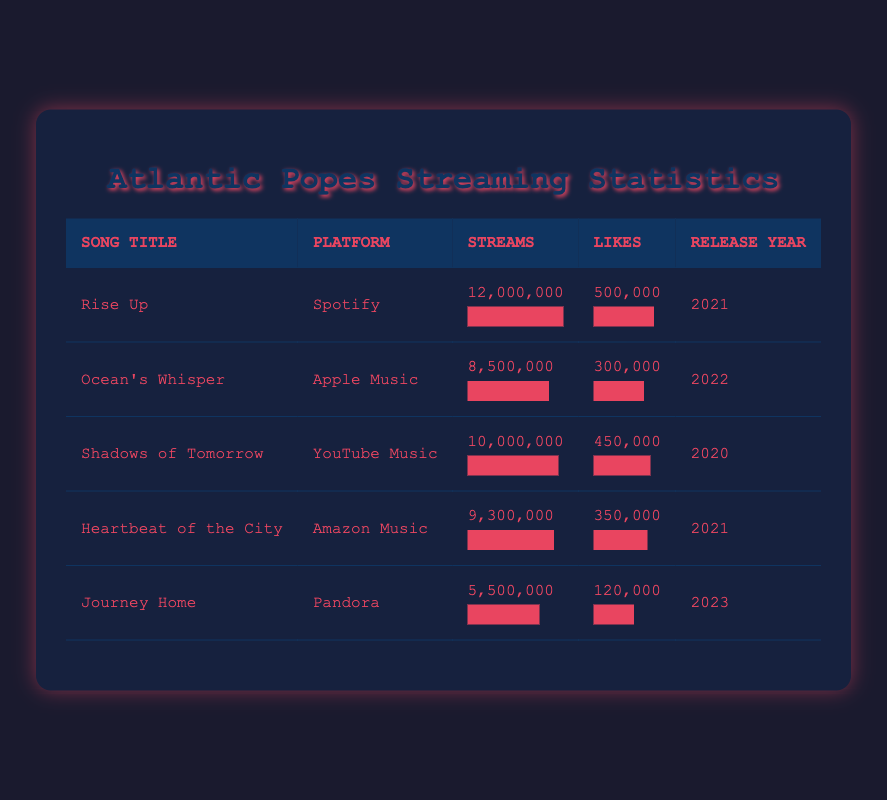What is the total number of streams for all songs listed? To find the total number of streams, we need to sum the streams for each song: 12,000,000 (Rise Up) + 8,500,000 (Ocean's Whisper) + 10,000,000 (Shadows of Tomorrow) + 9,300,000 (Heartbeat of the City) + 5,500,000 (Journey Home) = 45,300,000.
Answer: 45,300,000 Which song has the highest number of likes? By examining the Likes column, "Rise Up" has 500,000 likes, which is the highest compared to the other songs listed, which have 300,000 for "Ocean's Whisper," 450,000 for "Shadows of Tomorrow," 350,000 for "Heartbeat of the City," and 120,000 for "Journey Home."
Answer: Rise Up Did "Journey Home" receive more streams than "Ocean's Whisper"? "Journey Home" has 5,500,000 streams, and "Ocean's Whisper" has 8,500,000 streams, so 5,500,000 is less than 8,500,000, making the statement false.
Answer: No What is the average number of streams for the songs released in 2021? First, identify the songs released in 2021: "Rise Up" (12,000,000) and "Heartbeat of the City" (9,300,000). Their total streams are 12,000,000 + 9,300,000 = 21,300,000. Since there are 2 songs, the average is 21,300,000 / 2 = 10,650,000.
Answer: 10,650,000 Is "Ocean's Whisper" the only song released in 2022? Reviewing the release years, "Ocean's Whisper" is the only song listed for that year, while the others were released in 2020, 2021, and 2023. Therefore, the statement is true.
Answer: Yes 